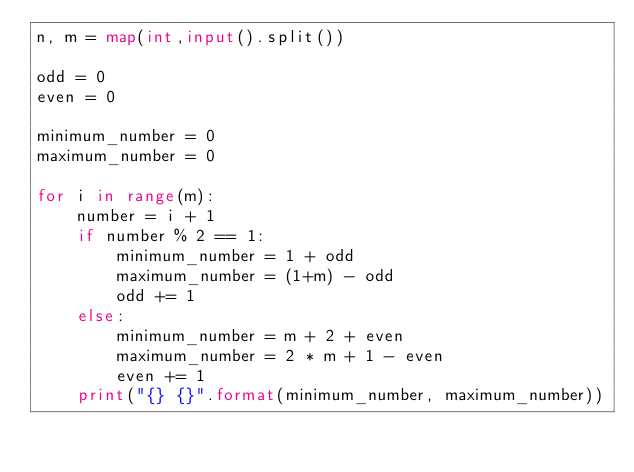Convert code to text. <code><loc_0><loc_0><loc_500><loc_500><_Python_>n, m = map(int,input().split())

odd = 0
even = 0

minimum_number = 0
maximum_number = 0

for i in range(m):
    number = i + 1
    if number % 2 == 1:
        minimum_number = 1 + odd
        maximum_number = (1+m) - odd
        odd += 1
    else:
        minimum_number = m + 2 + even
        maximum_number = 2 * m + 1 - even
        even += 1
    print("{} {}".format(minimum_number, maximum_number))
</code> 